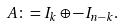Convert formula to latex. <formula><loc_0><loc_0><loc_500><loc_500>A \colon = I _ { k } \oplus - I _ { n - k } .</formula> 